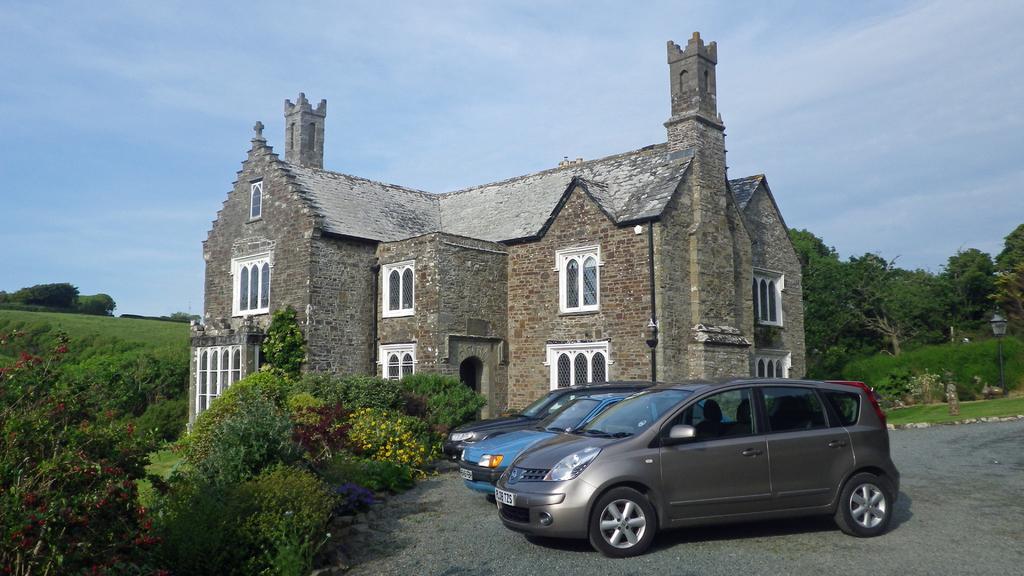How would you summarize this image in a sentence or two? In the picture we can see some cars are parked on the path near the building and on the both the sides of the building we can see the grass surface with plants and trees and in the background we can see the sky with clouds. 